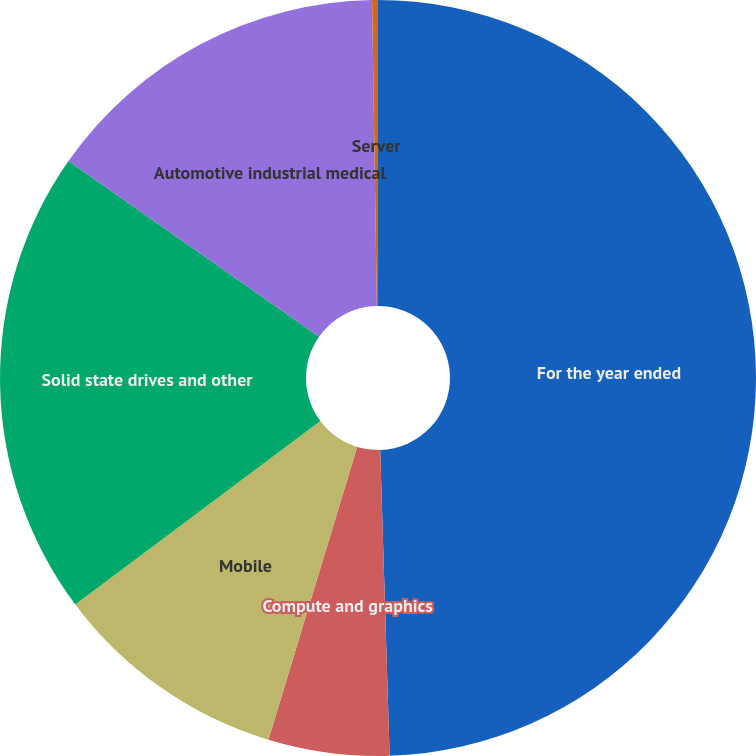<chart> <loc_0><loc_0><loc_500><loc_500><pie_chart><fcel>For the year ended<fcel>Compute and graphics<fcel>Mobile<fcel>Solid state drives and other<fcel>Automotive industrial medical<fcel>Server<nl><fcel>49.51%<fcel>5.17%<fcel>10.1%<fcel>19.95%<fcel>15.02%<fcel>0.25%<nl></chart> 